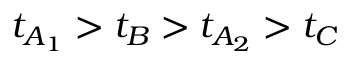Convert formula to latex. <formula><loc_0><loc_0><loc_500><loc_500>t _ { A _ { 1 } } > t _ { B } > t _ { A _ { 2 } } > t _ { C }</formula> 